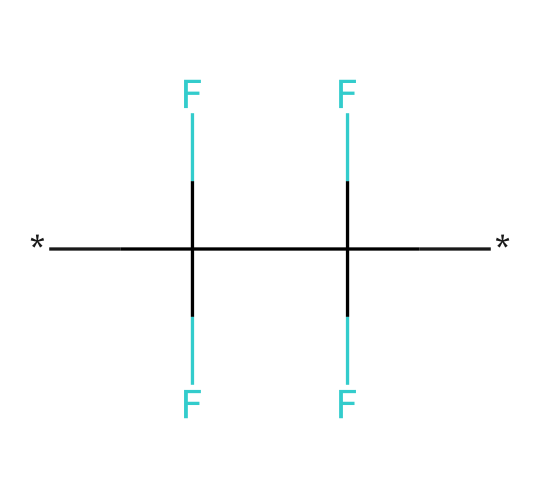What is the name of this chemical? The provided SMILES representation corresponds to polytetrafluoroethylene (PTFE). The presence of multiple fluorine atoms and carbon chains indicates that it is a polymer commonly used in non-stick coatings.
Answer: polytetrafluoroethylene How many carbon atoms are present in this structure? Analyzing the SMILES notation, there are two carbon atoms in the structure as indicated by the two 'C' entities in the representation before the brackets that depict the bonds to fluorine atoms.
Answer: two What is the main property of PTFE that makes it suitable for non-stick coatings? The chemical structure of PTFE, characterized by its high fluorine content and carbon backbone, provides low surface energy, making it non-stick. This low friction surface minimizes food adhesion, which is a crucial property for non-stick cookware.
Answer: low surface energy How many fluorine atoms are present in this structure? By examining the SMILES notation, there are six fluorine atoms attached to the two carbon atoms. Each carbon atom is attached to three fluorine atoms in the structure.
Answer: six What type of bonds are present between carbon and fluorine in this compound? The bonds between carbon and fluorine in PTFE are covalent bonds. Covalent bonds involve the sharing of electrons between atoms, and in PTFE, the strong bond between carbon and fluorine atoms contributes to the thermal stability and chemical resistance of the polymer.
Answer: covalent bonds Why is PTFE considered a lubricant? PTFE acts as a lubricant due to its unique molecular structure, which provides a slippery surface, reducing friction between moving parts. The arrangement of fluorine atoms helps to create a non-stick effect, allowing for smooth movement and preventing wear, crucial for lubrication applications.
Answer: slippery surface What is the main application of PTFE in everyday products? PTFE is widely recognized for its use in non-stick cookware, where its properties make cooking and cleaning easier. Additionally, its durability and resistance to chemicals lend to applications in seals, gaskets, and bearings.
Answer: non-stick cookware 